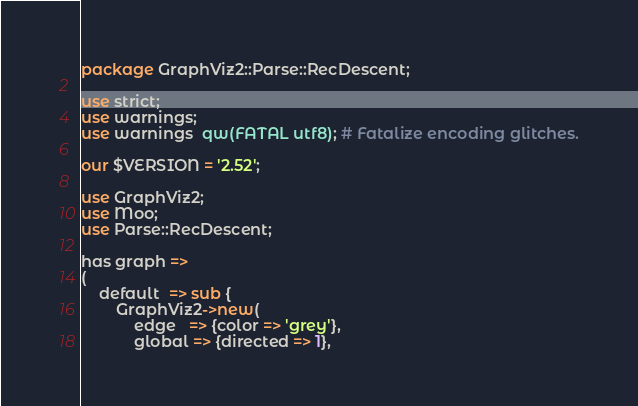<code> <loc_0><loc_0><loc_500><loc_500><_Perl_>package GraphViz2::Parse::RecDescent;

use strict;
use warnings;
use warnings  qw(FATAL utf8); # Fatalize encoding glitches.

our $VERSION = '2.52';

use GraphViz2;
use Moo;
use Parse::RecDescent;

has graph =>
(
	default  => sub {
		GraphViz2->new(
			edge   => {color => 'grey'},
			global => {directed => 1},</code> 